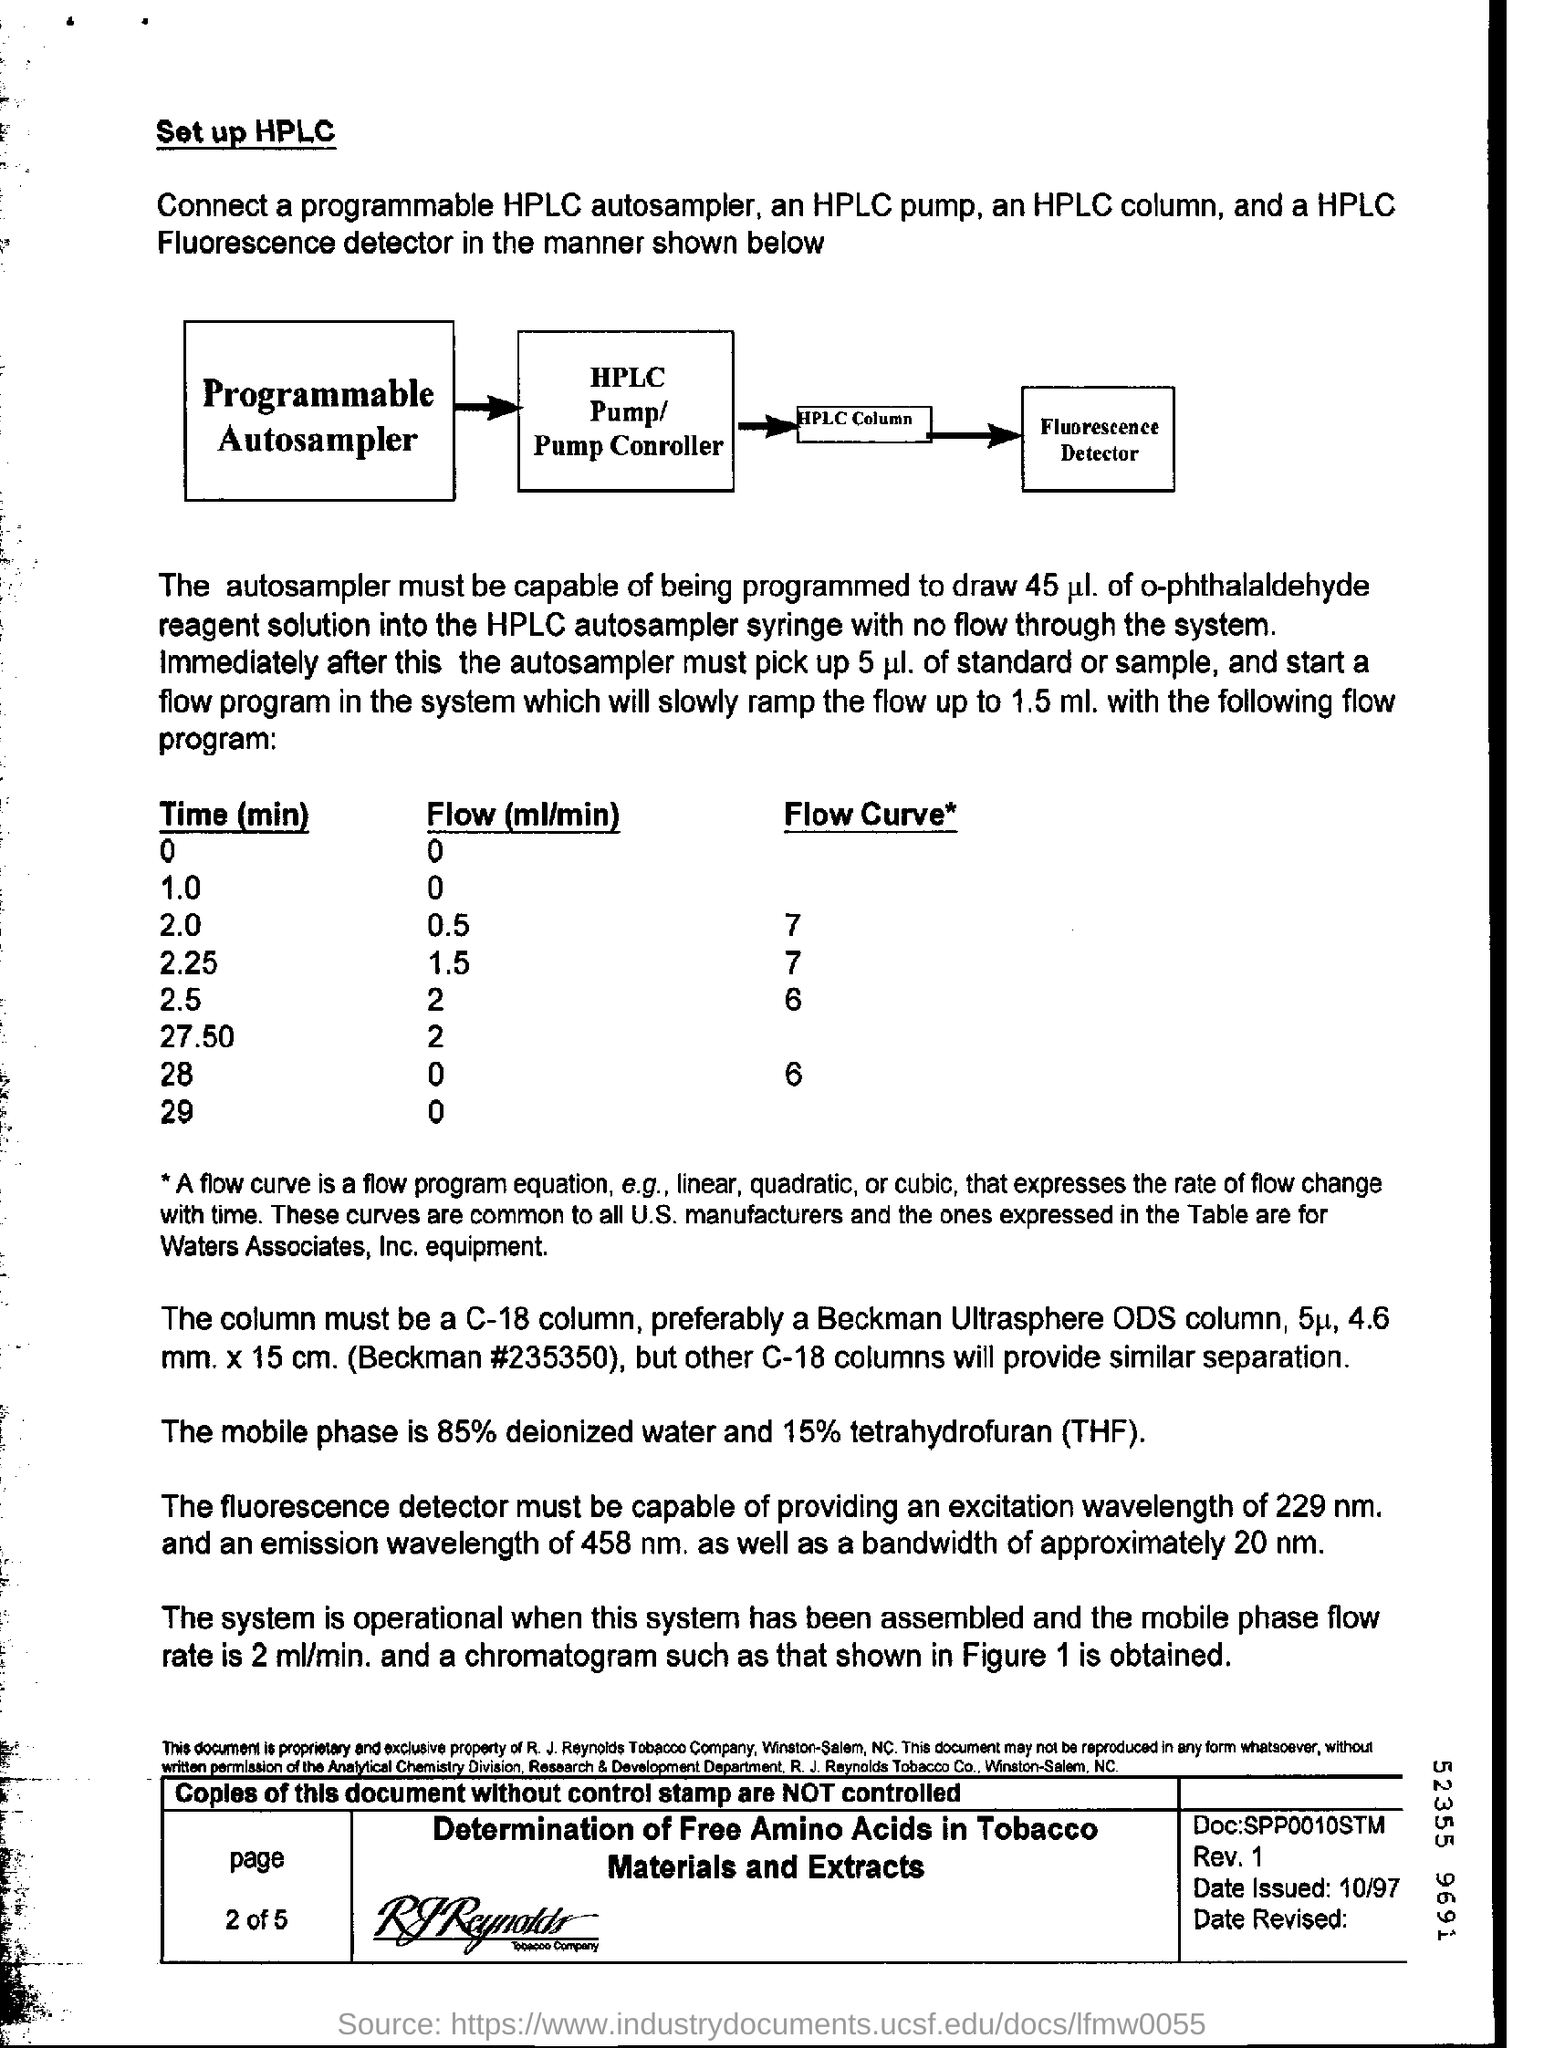Mention a couple of crucial points in this snapshot. The flow (ml/min) for time (min) 2.5 is [insert value]. The flow rate (ml/min) for a time of 29 minutes is unknown. The flow rate (in milliliters per minute) for a time of 2.25 minutes is 1.5... In the mobile phase, 85% deionized water is used. What is the flow rate (ml/min) for time (min) 28? The flow rate ranges from 0 to... 